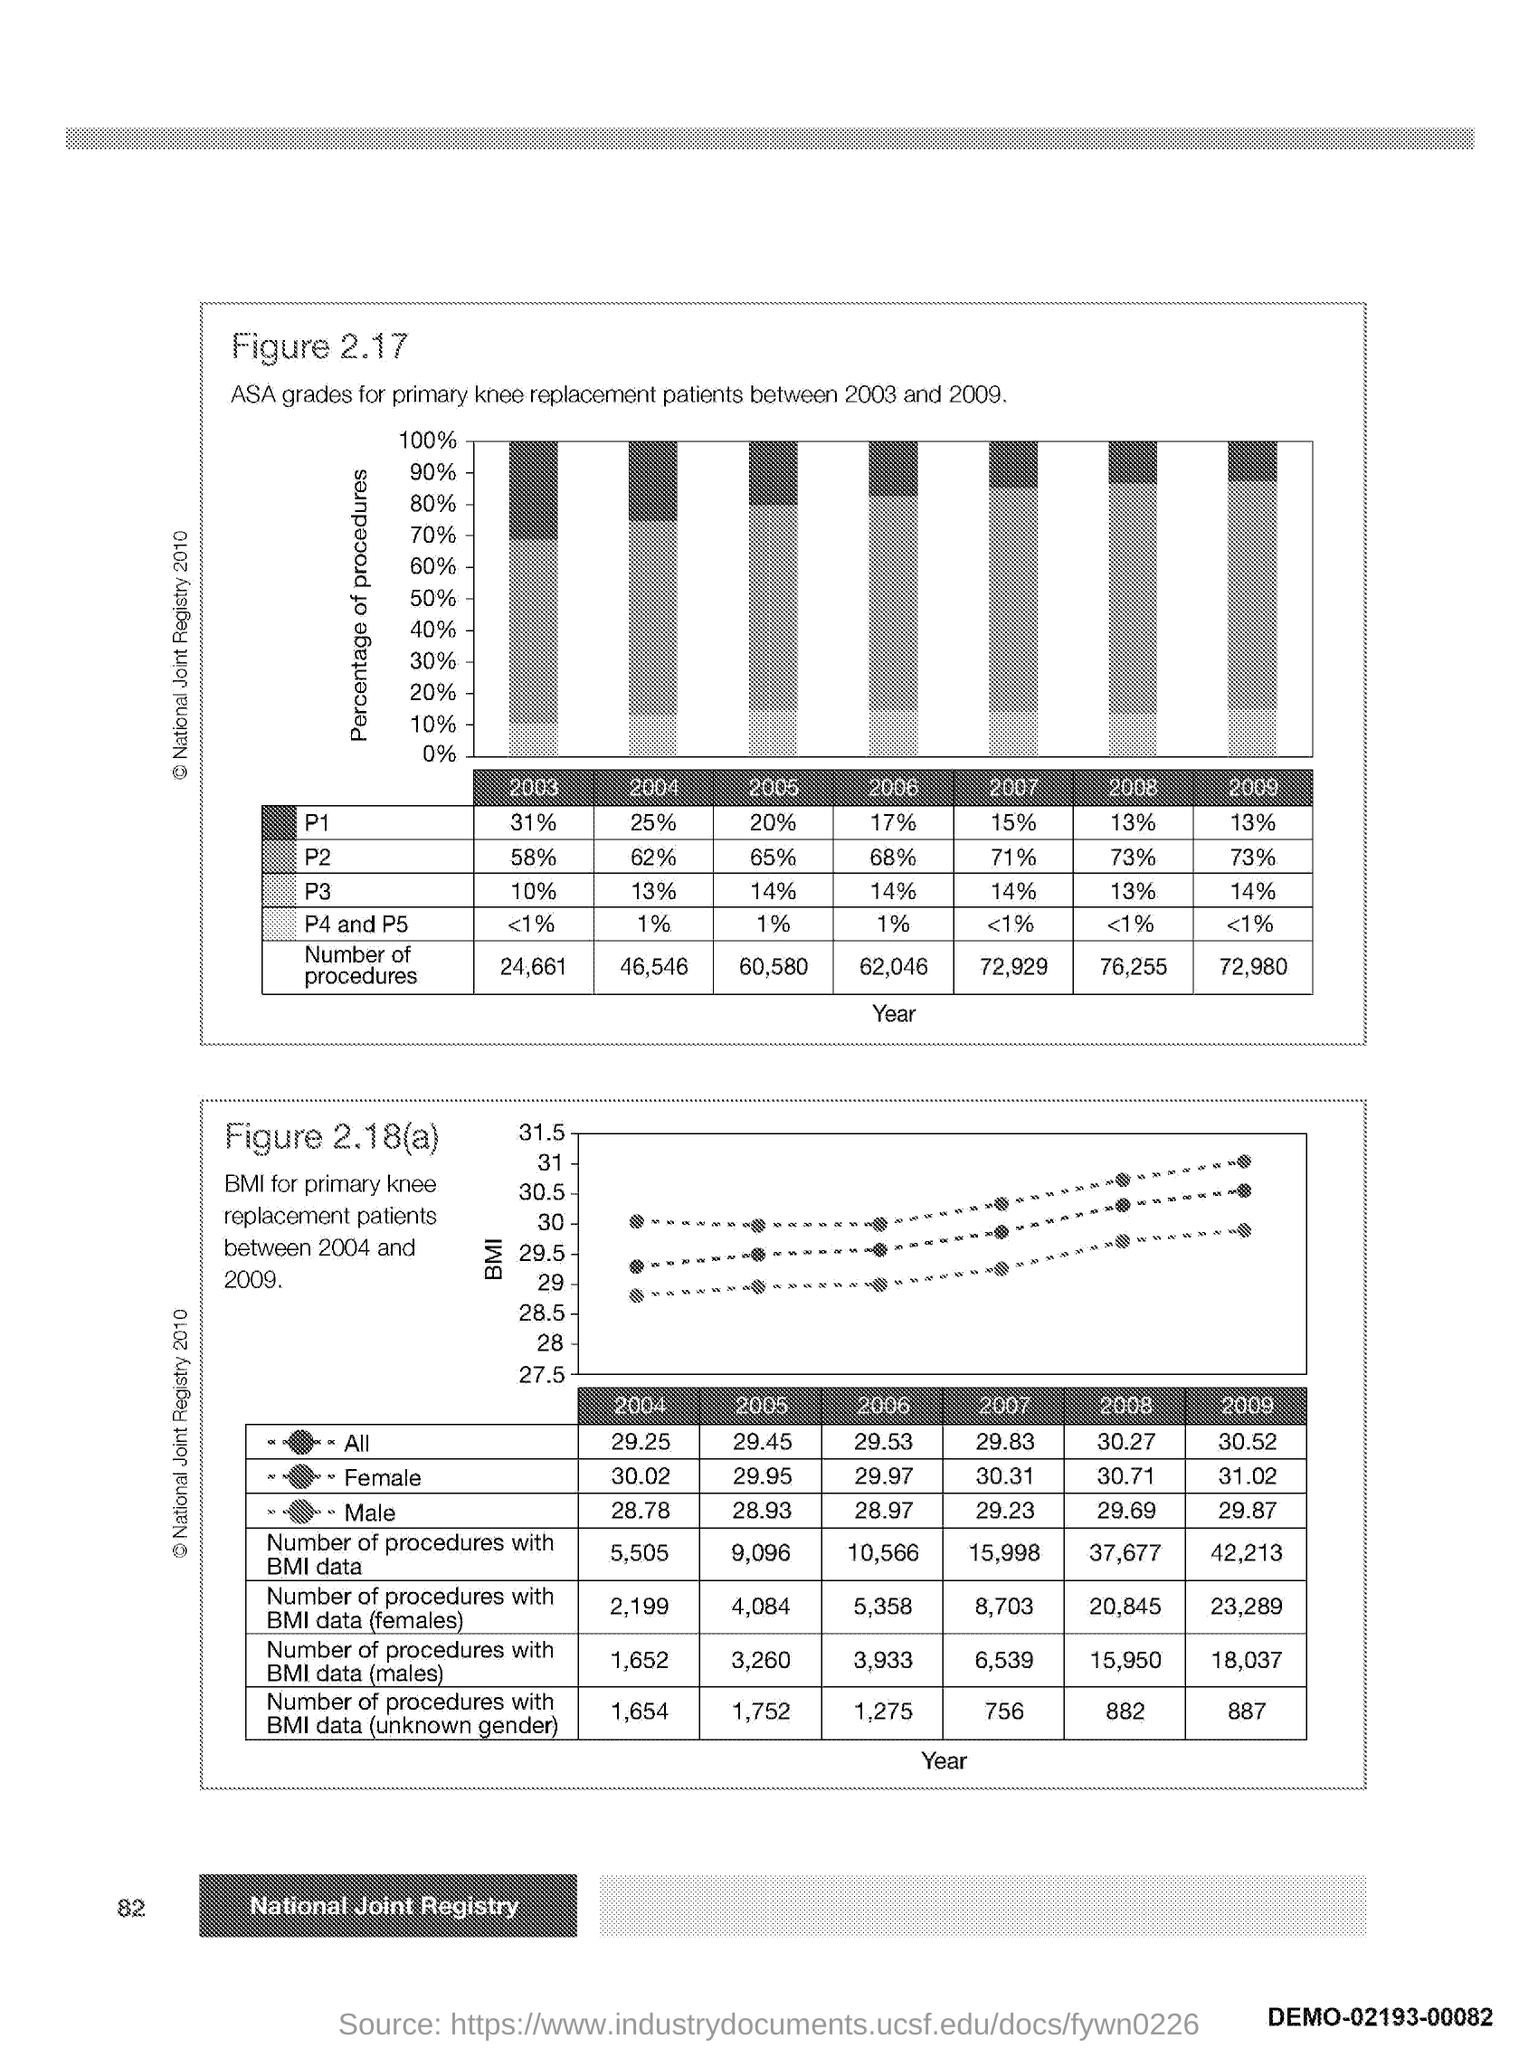What is the number at bottom left side of the page ?
Your answer should be compact. 82. 